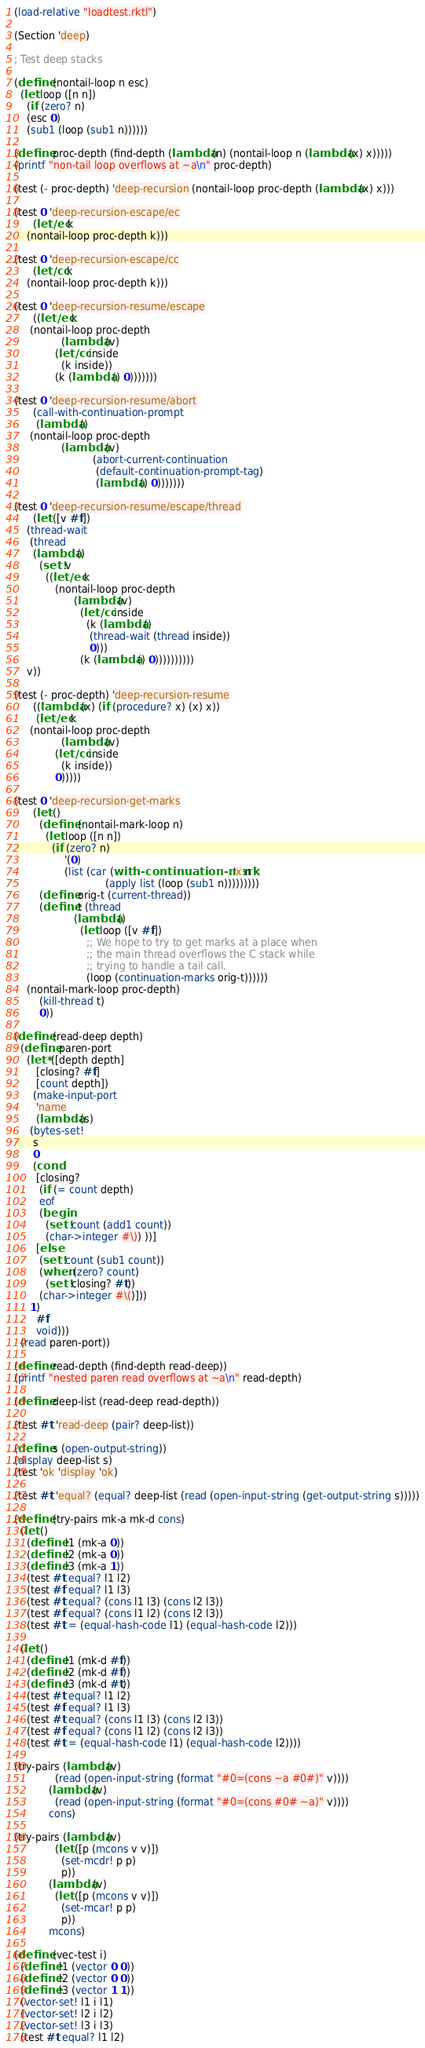<code> <loc_0><loc_0><loc_500><loc_500><_Racket_>
(load-relative "loadtest.rktl")

(Section 'deep)

; Test deep stacks

(define (nontail-loop n esc)
  (let loop ([n n])
    (if (zero? n)
	(esc 0)
	(sub1 (loop (sub1 n))))))

(define proc-depth (find-depth (lambda (n) (nontail-loop n (lambda (x) x)))))
(printf "non-tail loop overflows at ~a\n" proc-depth)
  
(test (- proc-depth) 'deep-recursion (nontail-loop proc-depth (lambda (x) x)))

(test 0 'deep-recursion-escape/ec
      (let/ec k
	(nontail-loop proc-depth k)))

(test 0 'deep-recursion-escape/cc
      (let/cc k
	(nontail-loop proc-depth k)))

(test 0 'deep-recursion-resume/escape
      ((let/ec k
	 (nontail-loop proc-depth
		       (lambda (v)
			 (let/cc inside
			   (k inside))
			 (k (lambda () 0)))))))

(test 0 'deep-recursion-resume/abort
      (call-with-continuation-prompt
       (lambda ()
	 (nontail-loop proc-depth
		       (lambda (v)
                         (abort-current-continuation
                          (default-continuation-prompt-tag)
                          (lambda () 0)))))))

(test 0 'deep-recursion-resume/escape/thread
      (let ([v #f])
	(thread-wait
	 (thread 
	  (lambda ()
	    (set! v 
		  ((let/ec k
		     (nontail-loop proc-depth
				   (lambda (v)
				     (let/cc inside
				       (k (lambda () 
					    (thread-wait (thread inside))
					    0)))
				     (k (lambda () 0))))))))))
	v))

(test (- proc-depth) 'deep-recursion-resume
      ((lambda (x) (if (procedure? x) (x) x))
       (let/ec k
	 (nontail-loop proc-depth
		       (lambda (v)
			 (let/cc inside
			   (k inside))
			 0)))))

(test 0 'deep-recursion-get-marks
      (let ()
        (define (nontail-mark-loop n)
          (let loop ([n n])
            (if (zero? n)
                '(0)
                (list (car (with-continuation-mark 'x n
                             (apply list (loop (sub1 n)))))))))
        (define orig-t (current-thread))
        (define t (thread
                   (lambda ()
                     (let loop ([v #f])
                       ;; We hope to try to get marks at a place when
                       ;; the main thread overflows the C stack while
                       ;; trying to handle a tail call.
                       (loop (continuation-marks orig-t))))))
	(nontail-mark-loop proc-depth)
        (kill-thread t)
        0))

(define (read-deep depth)
  (define paren-port
    (let* ([depth depth]
	   [closing? #f]
	   [count depth])
      (make-input-port
       'name
       (lambda (s)
	 (bytes-set!
	  s
	  0
	  (cond
	   [closing?
	    (if (= count depth)
		eof
		(begin
		  (set! count (add1 count))
		  (char->integer #\)) ))]
	   [else
	    (set! count (sub1 count))
	    (when (zero? count)
	      (set! closing? #t))
	    (char->integer #\()]))
	 1)
       #f
       void)))
  (read paren-port))

(define read-depth (find-depth read-deep))
(printf "nested paren read overflows at ~a\n" read-depth)

(define deep-list (read-deep read-depth))

(test #t 'read-deep (pair? deep-list))

(define s (open-output-string))
(display deep-list s)
(test 'ok 'display 'ok)

(test #t 'equal? (equal? deep-list (read (open-input-string (get-output-string s)))))

(define (try-pairs mk-a mk-d cons)
  (let ()
    (define l1 (mk-a 0))
    (define l2 (mk-a 0))
    (define l3 (mk-a 1))
    (test #t equal? l1 l2)
    (test #f equal? l1 l3)
    (test #t equal? (cons l1 l3) (cons l2 l3))
    (test #f equal? (cons l1 l2) (cons l2 l3))
    (test #t = (equal-hash-code l1) (equal-hash-code l2)))

  (let ()
    (define l1 (mk-d #f))
    (define l2 (mk-d #f))
    (define l3 (mk-d #t))
    (test #t equal? l1 l2)
    (test #f equal? l1 l3)
    (test #t equal? (cons l1 l3) (cons l2 l3))
    (test #f equal? (cons l1 l2) (cons l2 l3))
    (test #t = (equal-hash-code l1) (equal-hash-code l2))))

(try-pairs (lambda (v)
             (read (open-input-string (format "#0=(cons ~a #0#)" v))))
           (lambda (v)
             (read (open-input-string (format "#0=(cons #0# ~a)" v))))
           cons)

(try-pairs (lambda (v)
             (let ([p (mcons v v)])
               (set-mcdr! p p)
               p))
           (lambda (v)
             (let ([p (mcons v v)])
               (set-mcar! p p)
               p))
           mcons)

(define (vec-test i)
  (define l1 (vector 0 0))
  (define l2 (vector 0 0))
  (define l3 (vector 1 1))
  (vector-set! l1 i l1)
  (vector-set! l2 i l2)
  (vector-set! l3 i l3)
  (test #t equal? l1 l2)</code> 